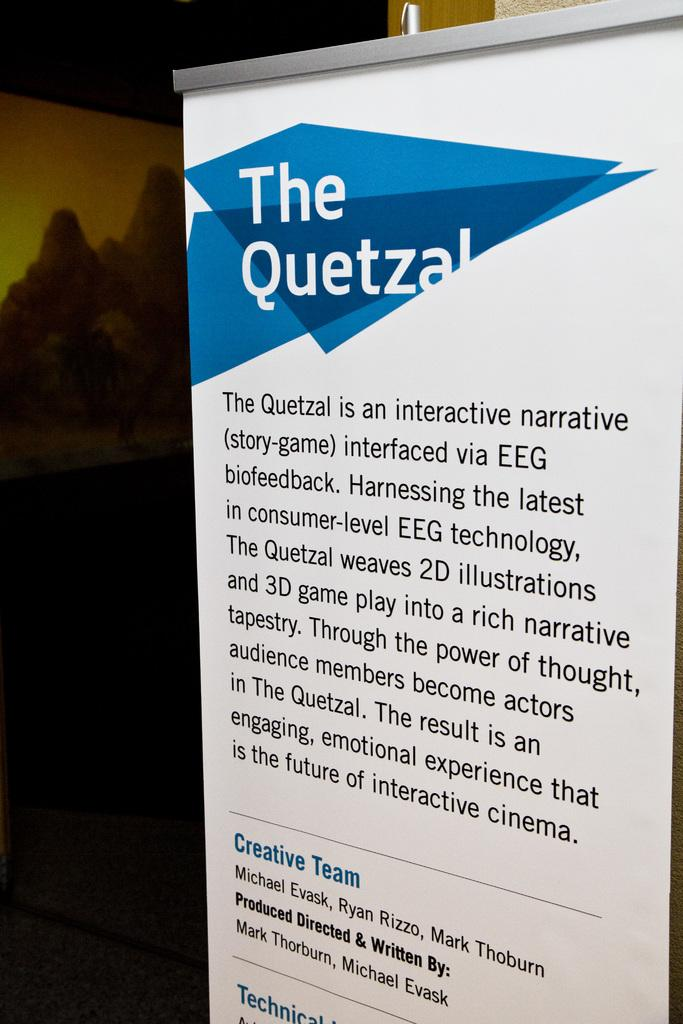<image>
Share a concise interpretation of the image provided. A sign provides information on the game The Quetzal. 